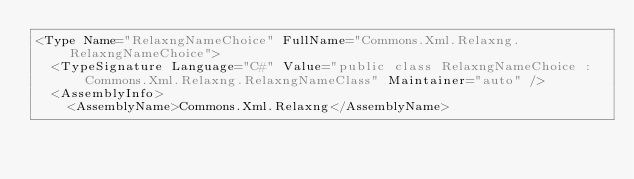Convert code to text. <code><loc_0><loc_0><loc_500><loc_500><_XML_><Type Name="RelaxngNameChoice" FullName="Commons.Xml.Relaxng.RelaxngNameChoice">
  <TypeSignature Language="C#" Value="public class RelaxngNameChoice : Commons.Xml.Relaxng.RelaxngNameClass" Maintainer="auto" />
  <AssemblyInfo>
    <AssemblyName>Commons.Xml.Relaxng</AssemblyName></code> 